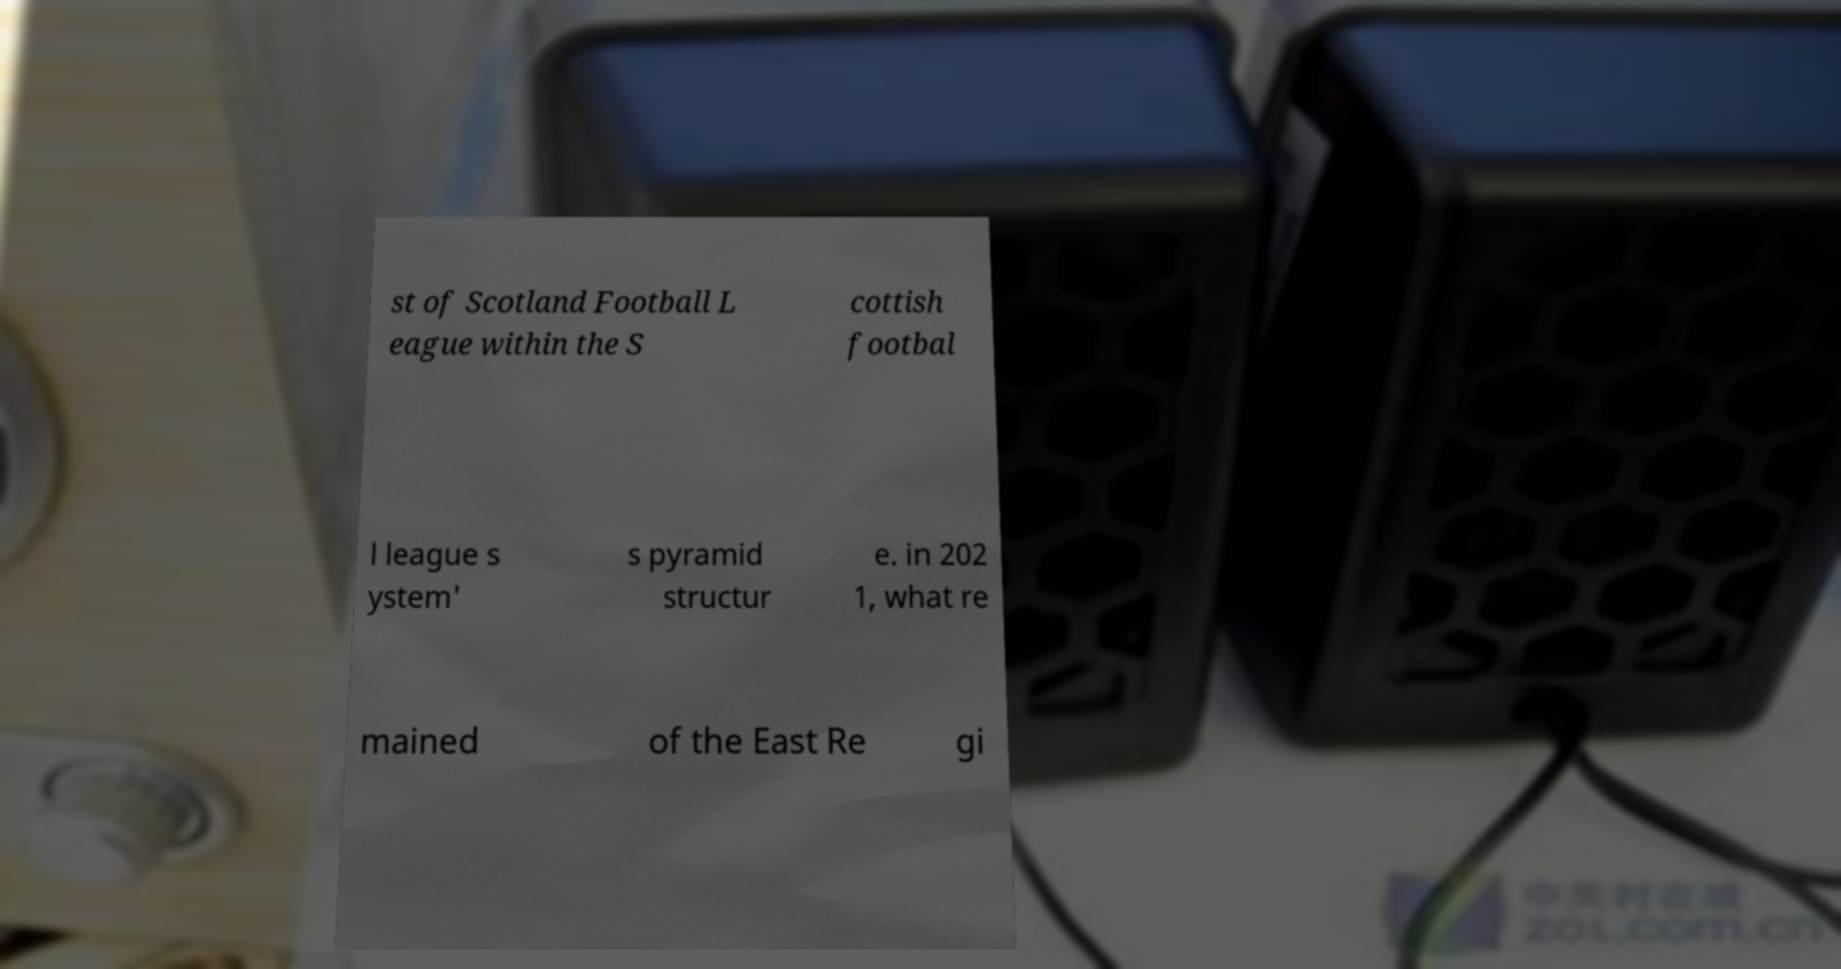Can you accurately transcribe the text from the provided image for me? st of Scotland Football L eague within the S cottish footbal l league s ystem' s pyramid structur e. in 202 1, what re mained of the East Re gi 